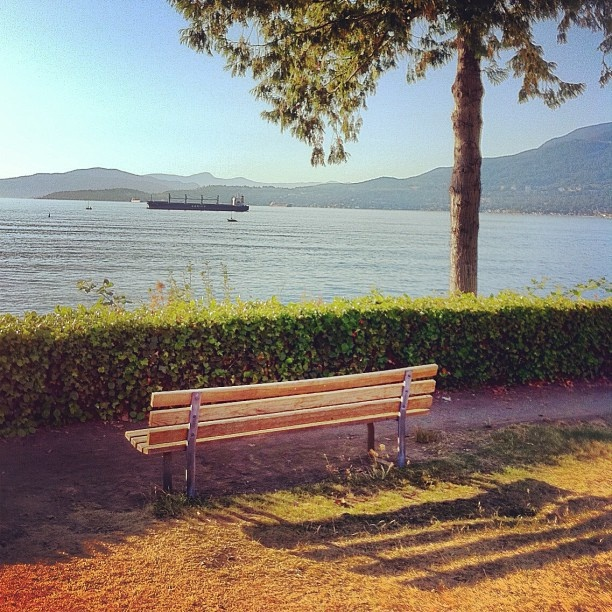Describe the objects in this image and their specific colors. I can see bench in lightblue, brown, tan, and maroon tones, boat in lightblue, gray, darkgray, and black tones, boat in lightblue, darkgray, gray, and lightgray tones, boat in lightblue, gray, black, and darkgray tones, and boat in lightblue, darkgray, lightgray, gray, and black tones in this image. 